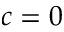<formula> <loc_0><loc_0><loc_500><loc_500>c = 0</formula> 